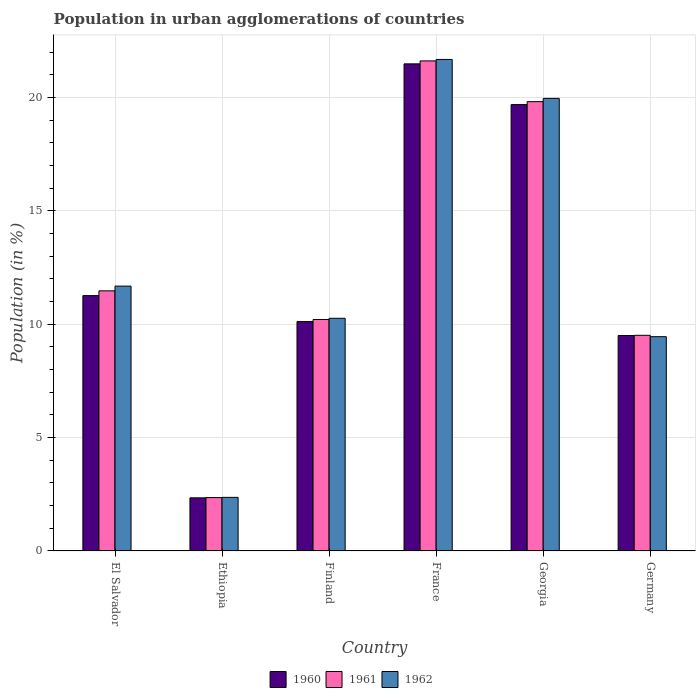How many different coloured bars are there?
Give a very brief answer. 3. Are the number of bars per tick equal to the number of legend labels?
Ensure brevity in your answer.  Yes. How many bars are there on the 4th tick from the left?
Provide a short and direct response. 3. How many bars are there on the 3rd tick from the right?
Provide a succinct answer. 3. What is the label of the 6th group of bars from the left?
Make the answer very short. Germany. In how many cases, is the number of bars for a given country not equal to the number of legend labels?
Your answer should be compact. 0. What is the percentage of population in urban agglomerations in 1962 in Ethiopia?
Your response must be concise. 2.36. Across all countries, what is the maximum percentage of population in urban agglomerations in 1960?
Your response must be concise. 21.49. Across all countries, what is the minimum percentage of population in urban agglomerations in 1962?
Your response must be concise. 2.36. In which country was the percentage of population in urban agglomerations in 1962 maximum?
Keep it short and to the point. France. In which country was the percentage of population in urban agglomerations in 1962 minimum?
Give a very brief answer. Ethiopia. What is the total percentage of population in urban agglomerations in 1961 in the graph?
Provide a short and direct response. 74.99. What is the difference between the percentage of population in urban agglomerations in 1960 in Ethiopia and that in France?
Your answer should be very brief. -19.14. What is the difference between the percentage of population in urban agglomerations in 1960 in Finland and the percentage of population in urban agglomerations in 1961 in Georgia?
Give a very brief answer. -9.7. What is the average percentage of population in urban agglomerations in 1962 per country?
Offer a very short reply. 12.57. What is the difference between the percentage of population in urban agglomerations of/in 1961 and percentage of population in urban agglomerations of/in 1962 in Georgia?
Offer a terse response. -0.14. In how many countries, is the percentage of population in urban agglomerations in 1961 greater than 18 %?
Provide a succinct answer. 2. What is the ratio of the percentage of population in urban agglomerations in 1960 in El Salvador to that in Germany?
Offer a very short reply. 1.19. Is the difference between the percentage of population in urban agglomerations in 1961 in Ethiopia and France greater than the difference between the percentage of population in urban agglomerations in 1962 in Ethiopia and France?
Make the answer very short. Yes. What is the difference between the highest and the second highest percentage of population in urban agglomerations in 1960?
Offer a terse response. -8.43. What is the difference between the highest and the lowest percentage of population in urban agglomerations in 1962?
Keep it short and to the point. 19.32. In how many countries, is the percentage of population in urban agglomerations in 1962 greater than the average percentage of population in urban agglomerations in 1962 taken over all countries?
Offer a terse response. 2. Is the sum of the percentage of population in urban agglomerations in 1962 in El Salvador and Germany greater than the maximum percentage of population in urban agglomerations in 1961 across all countries?
Keep it short and to the point. No. What does the 3rd bar from the left in France represents?
Offer a very short reply. 1962. How many bars are there?
Make the answer very short. 18. Are all the bars in the graph horizontal?
Provide a short and direct response. No. How many countries are there in the graph?
Your response must be concise. 6. Does the graph contain any zero values?
Your answer should be compact. No. Does the graph contain grids?
Give a very brief answer. Yes. Where does the legend appear in the graph?
Provide a short and direct response. Bottom center. How are the legend labels stacked?
Offer a terse response. Horizontal. What is the title of the graph?
Give a very brief answer. Population in urban agglomerations of countries. What is the label or title of the X-axis?
Your response must be concise. Country. What is the label or title of the Y-axis?
Offer a terse response. Population (in %). What is the Population (in %) of 1960 in El Salvador?
Your response must be concise. 11.26. What is the Population (in %) in 1961 in El Salvador?
Your answer should be very brief. 11.47. What is the Population (in %) of 1962 in El Salvador?
Your answer should be compact. 11.68. What is the Population (in %) in 1960 in Ethiopia?
Provide a succinct answer. 2.34. What is the Population (in %) of 1961 in Ethiopia?
Your response must be concise. 2.36. What is the Population (in %) of 1962 in Ethiopia?
Ensure brevity in your answer.  2.36. What is the Population (in %) of 1960 in Finland?
Ensure brevity in your answer.  10.12. What is the Population (in %) in 1961 in Finland?
Ensure brevity in your answer.  10.21. What is the Population (in %) in 1962 in Finland?
Ensure brevity in your answer.  10.26. What is the Population (in %) of 1960 in France?
Offer a terse response. 21.49. What is the Population (in %) of 1961 in France?
Your answer should be very brief. 21.62. What is the Population (in %) of 1962 in France?
Provide a succinct answer. 21.68. What is the Population (in %) of 1960 in Georgia?
Offer a very short reply. 19.69. What is the Population (in %) of 1961 in Georgia?
Your response must be concise. 19.82. What is the Population (in %) in 1962 in Georgia?
Your answer should be very brief. 19.96. What is the Population (in %) in 1960 in Germany?
Give a very brief answer. 9.5. What is the Population (in %) in 1961 in Germany?
Make the answer very short. 9.51. What is the Population (in %) of 1962 in Germany?
Give a very brief answer. 9.45. Across all countries, what is the maximum Population (in %) in 1960?
Offer a very short reply. 21.49. Across all countries, what is the maximum Population (in %) in 1961?
Provide a succinct answer. 21.62. Across all countries, what is the maximum Population (in %) of 1962?
Offer a terse response. 21.68. Across all countries, what is the minimum Population (in %) of 1960?
Provide a succinct answer. 2.34. Across all countries, what is the minimum Population (in %) in 1961?
Your response must be concise. 2.36. Across all countries, what is the minimum Population (in %) in 1962?
Offer a terse response. 2.36. What is the total Population (in %) in 1960 in the graph?
Offer a very short reply. 74.4. What is the total Population (in %) of 1961 in the graph?
Give a very brief answer. 74.99. What is the total Population (in %) in 1962 in the graph?
Make the answer very short. 75.41. What is the difference between the Population (in %) in 1960 in El Salvador and that in Ethiopia?
Offer a very short reply. 8.92. What is the difference between the Population (in %) of 1961 in El Salvador and that in Ethiopia?
Offer a very short reply. 9.12. What is the difference between the Population (in %) of 1962 in El Salvador and that in Ethiopia?
Provide a short and direct response. 9.32. What is the difference between the Population (in %) in 1960 in El Salvador and that in Finland?
Your response must be concise. 1.15. What is the difference between the Population (in %) in 1961 in El Salvador and that in Finland?
Ensure brevity in your answer.  1.26. What is the difference between the Population (in %) of 1962 in El Salvador and that in Finland?
Your answer should be very brief. 1.42. What is the difference between the Population (in %) of 1960 in El Salvador and that in France?
Offer a very short reply. -10.22. What is the difference between the Population (in %) in 1961 in El Salvador and that in France?
Your answer should be compact. -10.14. What is the difference between the Population (in %) in 1962 in El Salvador and that in France?
Offer a terse response. -10. What is the difference between the Population (in %) in 1960 in El Salvador and that in Georgia?
Ensure brevity in your answer.  -8.43. What is the difference between the Population (in %) in 1961 in El Salvador and that in Georgia?
Provide a short and direct response. -8.35. What is the difference between the Population (in %) of 1962 in El Salvador and that in Georgia?
Provide a succinct answer. -8.28. What is the difference between the Population (in %) of 1960 in El Salvador and that in Germany?
Your answer should be compact. 1.76. What is the difference between the Population (in %) of 1961 in El Salvador and that in Germany?
Your answer should be compact. 1.96. What is the difference between the Population (in %) of 1962 in El Salvador and that in Germany?
Provide a succinct answer. 2.23. What is the difference between the Population (in %) in 1960 in Ethiopia and that in Finland?
Your response must be concise. -7.77. What is the difference between the Population (in %) in 1961 in Ethiopia and that in Finland?
Provide a succinct answer. -7.86. What is the difference between the Population (in %) in 1962 in Ethiopia and that in Finland?
Provide a short and direct response. -7.9. What is the difference between the Population (in %) in 1960 in Ethiopia and that in France?
Provide a short and direct response. -19.14. What is the difference between the Population (in %) of 1961 in Ethiopia and that in France?
Offer a terse response. -19.26. What is the difference between the Population (in %) in 1962 in Ethiopia and that in France?
Offer a very short reply. -19.32. What is the difference between the Population (in %) of 1960 in Ethiopia and that in Georgia?
Your answer should be compact. -17.34. What is the difference between the Population (in %) of 1961 in Ethiopia and that in Georgia?
Ensure brevity in your answer.  -17.46. What is the difference between the Population (in %) of 1962 in Ethiopia and that in Georgia?
Provide a short and direct response. -17.6. What is the difference between the Population (in %) in 1960 in Ethiopia and that in Germany?
Keep it short and to the point. -7.16. What is the difference between the Population (in %) of 1961 in Ethiopia and that in Germany?
Offer a very short reply. -7.16. What is the difference between the Population (in %) in 1962 in Ethiopia and that in Germany?
Make the answer very short. -7.09. What is the difference between the Population (in %) in 1960 in Finland and that in France?
Provide a succinct answer. -11.37. What is the difference between the Population (in %) in 1961 in Finland and that in France?
Keep it short and to the point. -11.41. What is the difference between the Population (in %) of 1962 in Finland and that in France?
Make the answer very short. -11.42. What is the difference between the Population (in %) in 1960 in Finland and that in Georgia?
Ensure brevity in your answer.  -9.57. What is the difference between the Population (in %) in 1961 in Finland and that in Georgia?
Offer a terse response. -9.61. What is the difference between the Population (in %) of 1962 in Finland and that in Georgia?
Your answer should be compact. -9.7. What is the difference between the Population (in %) in 1960 in Finland and that in Germany?
Provide a short and direct response. 0.62. What is the difference between the Population (in %) in 1961 in Finland and that in Germany?
Give a very brief answer. 0.7. What is the difference between the Population (in %) in 1962 in Finland and that in Germany?
Ensure brevity in your answer.  0.81. What is the difference between the Population (in %) in 1960 in France and that in Georgia?
Your answer should be compact. 1.8. What is the difference between the Population (in %) in 1961 in France and that in Georgia?
Your answer should be compact. 1.8. What is the difference between the Population (in %) in 1962 in France and that in Georgia?
Your answer should be compact. 1.72. What is the difference between the Population (in %) in 1960 in France and that in Germany?
Your response must be concise. 11.98. What is the difference between the Population (in %) of 1961 in France and that in Germany?
Offer a terse response. 12.1. What is the difference between the Population (in %) of 1962 in France and that in Germany?
Your answer should be compact. 12.23. What is the difference between the Population (in %) of 1960 in Georgia and that in Germany?
Provide a succinct answer. 10.19. What is the difference between the Population (in %) in 1961 in Georgia and that in Germany?
Ensure brevity in your answer.  10.31. What is the difference between the Population (in %) in 1962 in Georgia and that in Germany?
Offer a very short reply. 10.51. What is the difference between the Population (in %) in 1960 in El Salvador and the Population (in %) in 1961 in Ethiopia?
Give a very brief answer. 8.91. What is the difference between the Population (in %) in 1960 in El Salvador and the Population (in %) in 1962 in Ethiopia?
Ensure brevity in your answer.  8.9. What is the difference between the Population (in %) in 1961 in El Salvador and the Population (in %) in 1962 in Ethiopia?
Make the answer very short. 9.11. What is the difference between the Population (in %) in 1960 in El Salvador and the Population (in %) in 1961 in Finland?
Provide a short and direct response. 1.05. What is the difference between the Population (in %) in 1960 in El Salvador and the Population (in %) in 1962 in Finland?
Provide a short and direct response. 1. What is the difference between the Population (in %) in 1961 in El Salvador and the Population (in %) in 1962 in Finland?
Provide a short and direct response. 1.21. What is the difference between the Population (in %) of 1960 in El Salvador and the Population (in %) of 1961 in France?
Your response must be concise. -10.35. What is the difference between the Population (in %) of 1960 in El Salvador and the Population (in %) of 1962 in France?
Your answer should be very brief. -10.42. What is the difference between the Population (in %) in 1961 in El Salvador and the Population (in %) in 1962 in France?
Give a very brief answer. -10.21. What is the difference between the Population (in %) in 1960 in El Salvador and the Population (in %) in 1961 in Georgia?
Your answer should be very brief. -8.56. What is the difference between the Population (in %) in 1960 in El Salvador and the Population (in %) in 1962 in Georgia?
Make the answer very short. -8.7. What is the difference between the Population (in %) of 1961 in El Salvador and the Population (in %) of 1962 in Georgia?
Provide a succinct answer. -8.49. What is the difference between the Population (in %) in 1960 in El Salvador and the Population (in %) in 1961 in Germany?
Make the answer very short. 1.75. What is the difference between the Population (in %) in 1960 in El Salvador and the Population (in %) in 1962 in Germany?
Ensure brevity in your answer.  1.81. What is the difference between the Population (in %) of 1961 in El Salvador and the Population (in %) of 1962 in Germany?
Your answer should be compact. 2.02. What is the difference between the Population (in %) in 1960 in Ethiopia and the Population (in %) in 1961 in Finland?
Provide a succinct answer. -7.87. What is the difference between the Population (in %) in 1960 in Ethiopia and the Population (in %) in 1962 in Finland?
Your answer should be compact. -7.92. What is the difference between the Population (in %) of 1961 in Ethiopia and the Population (in %) of 1962 in Finland?
Provide a succinct answer. -7.91. What is the difference between the Population (in %) in 1960 in Ethiopia and the Population (in %) in 1961 in France?
Provide a short and direct response. -19.27. What is the difference between the Population (in %) in 1960 in Ethiopia and the Population (in %) in 1962 in France?
Your answer should be very brief. -19.34. What is the difference between the Population (in %) in 1961 in Ethiopia and the Population (in %) in 1962 in France?
Ensure brevity in your answer.  -19.32. What is the difference between the Population (in %) of 1960 in Ethiopia and the Population (in %) of 1961 in Georgia?
Provide a short and direct response. -17.48. What is the difference between the Population (in %) in 1960 in Ethiopia and the Population (in %) in 1962 in Georgia?
Provide a short and direct response. -17.62. What is the difference between the Population (in %) in 1961 in Ethiopia and the Population (in %) in 1962 in Georgia?
Offer a very short reply. -17.61. What is the difference between the Population (in %) of 1960 in Ethiopia and the Population (in %) of 1961 in Germany?
Provide a succinct answer. -7.17. What is the difference between the Population (in %) of 1960 in Ethiopia and the Population (in %) of 1962 in Germany?
Your answer should be very brief. -7.11. What is the difference between the Population (in %) of 1961 in Ethiopia and the Population (in %) of 1962 in Germany?
Provide a succinct answer. -7.1. What is the difference between the Population (in %) in 1960 in Finland and the Population (in %) in 1961 in France?
Keep it short and to the point. -11.5. What is the difference between the Population (in %) in 1960 in Finland and the Population (in %) in 1962 in France?
Provide a short and direct response. -11.56. What is the difference between the Population (in %) of 1961 in Finland and the Population (in %) of 1962 in France?
Offer a very short reply. -11.47. What is the difference between the Population (in %) of 1960 in Finland and the Population (in %) of 1961 in Georgia?
Provide a short and direct response. -9.7. What is the difference between the Population (in %) in 1960 in Finland and the Population (in %) in 1962 in Georgia?
Provide a succinct answer. -9.84. What is the difference between the Population (in %) of 1961 in Finland and the Population (in %) of 1962 in Georgia?
Ensure brevity in your answer.  -9.75. What is the difference between the Population (in %) of 1960 in Finland and the Population (in %) of 1961 in Germany?
Your response must be concise. 0.6. What is the difference between the Population (in %) in 1960 in Finland and the Population (in %) in 1962 in Germany?
Provide a succinct answer. 0.67. What is the difference between the Population (in %) of 1961 in Finland and the Population (in %) of 1962 in Germany?
Keep it short and to the point. 0.76. What is the difference between the Population (in %) of 1960 in France and the Population (in %) of 1961 in Georgia?
Provide a succinct answer. 1.67. What is the difference between the Population (in %) of 1960 in France and the Population (in %) of 1962 in Georgia?
Give a very brief answer. 1.52. What is the difference between the Population (in %) in 1961 in France and the Population (in %) in 1962 in Georgia?
Make the answer very short. 1.65. What is the difference between the Population (in %) in 1960 in France and the Population (in %) in 1961 in Germany?
Keep it short and to the point. 11.97. What is the difference between the Population (in %) of 1960 in France and the Population (in %) of 1962 in Germany?
Keep it short and to the point. 12.03. What is the difference between the Population (in %) of 1961 in France and the Population (in %) of 1962 in Germany?
Your answer should be compact. 12.16. What is the difference between the Population (in %) in 1960 in Georgia and the Population (in %) in 1961 in Germany?
Offer a very short reply. 10.18. What is the difference between the Population (in %) in 1960 in Georgia and the Population (in %) in 1962 in Germany?
Provide a short and direct response. 10.24. What is the difference between the Population (in %) of 1961 in Georgia and the Population (in %) of 1962 in Germany?
Give a very brief answer. 10.37. What is the average Population (in %) of 1960 per country?
Your response must be concise. 12.4. What is the average Population (in %) in 1961 per country?
Offer a very short reply. 12.5. What is the average Population (in %) in 1962 per country?
Your answer should be very brief. 12.57. What is the difference between the Population (in %) of 1960 and Population (in %) of 1961 in El Salvador?
Offer a terse response. -0.21. What is the difference between the Population (in %) in 1960 and Population (in %) in 1962 in El Salvador?
Your answer should be compact. -0.42. What is the difference between the Population (in %) of 1961 and Population (in %) of 1962 in El Salvador?
Offer a terse response. -0.21. What is the difference between the Population (in %) of 1960 and Population (in %) of 1961 in Ethiopia?
Give a very brief answer. -0.01. What is the difference between the Population (in %) of 1960 and Population (in %) of 1962 in Ethiopia?
Give a very brief answer. -0.02. What is the difference between the Population (in %) in 1961 and Population (in %) in 1962 in Ethiopia?
Offer a very short reply. -0.01. What is the difference between the Population (in %) in 1960 and Population (in %) in 1961 in Finland?
Offer a very short reply. -0.09. What is the difference between the Population (in %) in 1960 and Population (in %) in 1962 in Finland?
Provide a succinct answer. -0.15. What is the difference between the Population (in %) of 1961 and Population (in %) of 1962 in Finland?
Keep it short and to the point. -0.05. What is the difference between the Population (in %) of 1960 and Population (in %) of 1961 in France?
Your response must be concise. -0.13. What is the difference between the Population (in %) of 1960 and Population (in %) of 1962 in France?
Keep it short and to the point. -0.19. What is the difference between the Population (in %) of 1961 and Population (in %) of 1962 in France?
Provide a short and direct response. -0.06. What is the difference between the Population (in %) of 1960 and Population (in %) of 1961 in Georgia?
Give a very brief answer. -0.13. What is the difference between the Population (in %) in 1960 and Population (in %) in 1962 in Georgia?
Your response must be concise. -0.27. What is the difference between the Population (in %) of 1961 and Population (in %) of 1962 in Georgia?
Provide a short and direct response. -0.14. What is the difference between the Population (in %) in 1960 and Population (in %) in 1961 in Germany?
Give a very brief answer. -0.01. What is the difference between the Population (in %) of 1960 and Population (in %) of 1962 in Germany?
Ensure brevity in your answer.  0.05. What is the difference between the Population (in %) of 1961 and Population (in %) of 1962 in Germany?
Make the answer very short. 0.06. What is the ratio of the Population (in %) of 1960 in El Salvador to that in Ethiopia?
Provide a succinct answer. 4.81. What is the ratio of the Population (in %) in 1961 in El Salvador to that in Ethiopia?
Offer a very short reply. 4.87. What is the ratio of the Population (in %) in 1962 in El Salvador to that in Ethiopia?
Your answer should be very brief. 4.94. What is the ratio of the Population (in %) of 1960 in El Salvador to that in Finland?
Give a very brief answer. 1.11. What is the ratio of the Population (in %) in 1961 in El Salvador to that in Finland?
Your answer should be compact. 1.12. What is the ratio of the Population (in %) of 1962 in El Salvador to that in Finland?
Your response must be concise. 1.14. What is the ratio of the Population (in %) in 1960 in El Salvador to that in France?
Give a very brief answer. 0.52. What is the ratio of the Population (in %) of 1961 in El Salvador to that in France?
Make the answer very short. 0.53. What is the ratio of the Population (in %) in 1962 in El Salvador to that in France?
Keep it short and to the point. 0.54. What is the ratio of the Population (in %) in 1960 in El Salvador to that in Georgia?
Your answer should be compact. 0.57. What is the ratio of the Population (in %) of 1961 in El Salvador to that in Georgia?
Provide a short and direct response. 0.58. What is the ratio of the Population (in %) in 1962 in El Salvador to that in Georgia?
Give a very brief answer. 0.59. What is the ratio of the Population (in %) of 1960 in El Salvador to that in Germany?
Provide a succinct answer. 1.19. What is the ratio of the Population (in %) in 1961 in El Salvador to that in Germany?
Offer a terse response. 1.21. What is the ratio of the Population (in %) of 1962 in El Salvador to that in Germany?
Your answer should be very brief. 1.24. What is the ratio of the Population (in %) in 1960 in Ethiopia to that in Finland?
Your answer should be very brief. 0.23. What is the ratio of the Population (in %) of 1961 in Ethiopia to that in Finland?
Give a very brief answer. 0.23. What is the ratio of the Population (in %) of 1962 in Ethiopia to that in Finland?
Offer a very short reply. 0.23. What is the ratio of the Population (in %) in 1960 in Ethiopia to that in France?
Ensure brevity in your answer.  0.11. What is the ratio of the Population (in %) of 1961 in Ethiopia to that in France?
Ensure brevity in your answer.  0.11. What is the ratio of the Population (in %) of 1962 in Ethiopia to that in France?
Make the answer very short. 0.11. What is the ratio of the Population (in %) in 1960 in Ethiopia to that in Georgia?
Provide a succinct answer. 0.12. What is the ratio of the Population (in %) of 1961 in Ethiopia to that in Georgia?
Your answer should be very brief. 0.12. What is the ratio of the Population (in %) of 1962 in Ethiopia to that in Georgia?
Your response must be concise. 0.12. What is the ratio of the Population (in %) of 1960 in Ethiopia to that in Germany?
Ensure brevity in your answer.  0.25. What is the ratio of the Population (in %) of 1961 in Ethiopia to that in Germany?
Your response must be concise. 0.25. What is the ratio of the Population (in %) in 1962 in Ethiopia to that in Germany?
Provide a succinct answer. 0.25. What is the ratio of the Population (in %) in 1960 in Finland to that in France?
Your answer should be very brief. 0.47. What is the ratio of the Population (in %) in 1961 in Finland to that in France?
Keep it short and to the point. 0.47. What is the ratio of the Population (in %) in 1962 in Finland to that in France?
Ensure brevity in your answer.  0.47. What is the ratio of the Population (in %) in 1960 in Finland to that in Georgia?
Offer a very short reply. 0.51. What is the ratio of the Population (in %) of 1961 in Finland to that in Georgia?
Your answer should be compact. 0.52. What is the ratio of the Population (in %) of 1962 in Finland to that in Georgia?
Ensure brevity in your answer.  0.51. What is the ratio of the Population (in %) in 1960 in Finland to that in Germany?
Your answer should be very brief. 1.06. What is the ratio of the Population (in %) of 1961 in Finland to that in Germany?
Provide a succinct answer. 1.07. What is the ratio of the Population (in %) in 1962 in Finland to that in Germany?
Offer a very short reply. 1.09. What is the ratio of the Population (in %) in 1960 in France to that in Georgia?
Your answer should be very brief. 1.09. What is the ratio of the Population (in %) of 1961 in France to that in Georgia?
Offer a very short reply. 1.09. What is the ratio of the Population (in %) of 1962 in France to that in Georgia?
Your answer should be compact. 1.09. What is the ratio of the Population (in %) of 1960 in France to that in Germany?
Your answer should be compact. 2.26. What is the ratio of the Population (in %) of 1961 in France to that in Germany?
Keep it short and to the point. 2.27. What is the ratio of the Population (in %) in 1962 in France to that in Germany?
Your answer should be very brief. 2.29. What is the ratio of the Population (in %) in 1960 in Georgia to that in Germany?
Make the answer very short. 2.07. What is the ratio of the Population (in %) of 1961 in Georgia to that in Germany?
Keep it short and to the point. 2.08. What is the ratio of the Population (in %) of 1962 in Georgia to that in Germany?
Give a very brief answer. 2.11. What is the difference between the highest and the second highest Population (in %) in 1960?
Ensure brevity in your answer.  1.8. What is the difference between the highest and the second highest Population (in %) of 1961?
Your answer should be very brief. 1.8. What is the difference between the highest and the second highest Population (in %) in 1962?
Keep it short and to the point. 1.72. What is the difference between the highest and the lowest Population (in %) of 1960?
Give a very brief answer. 19.14. What is the difference between the highest and the lowest Population (in %) of 1961?
Ensure brevity in your answer.  19.26. What is the difference between the highest and the lowest Population (in %) of 1962?
Provide a short and direct response. 19.32. 